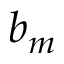<formula> <loc_0><loc_0><loc_500><loc_500>b _ { m }</formula> 